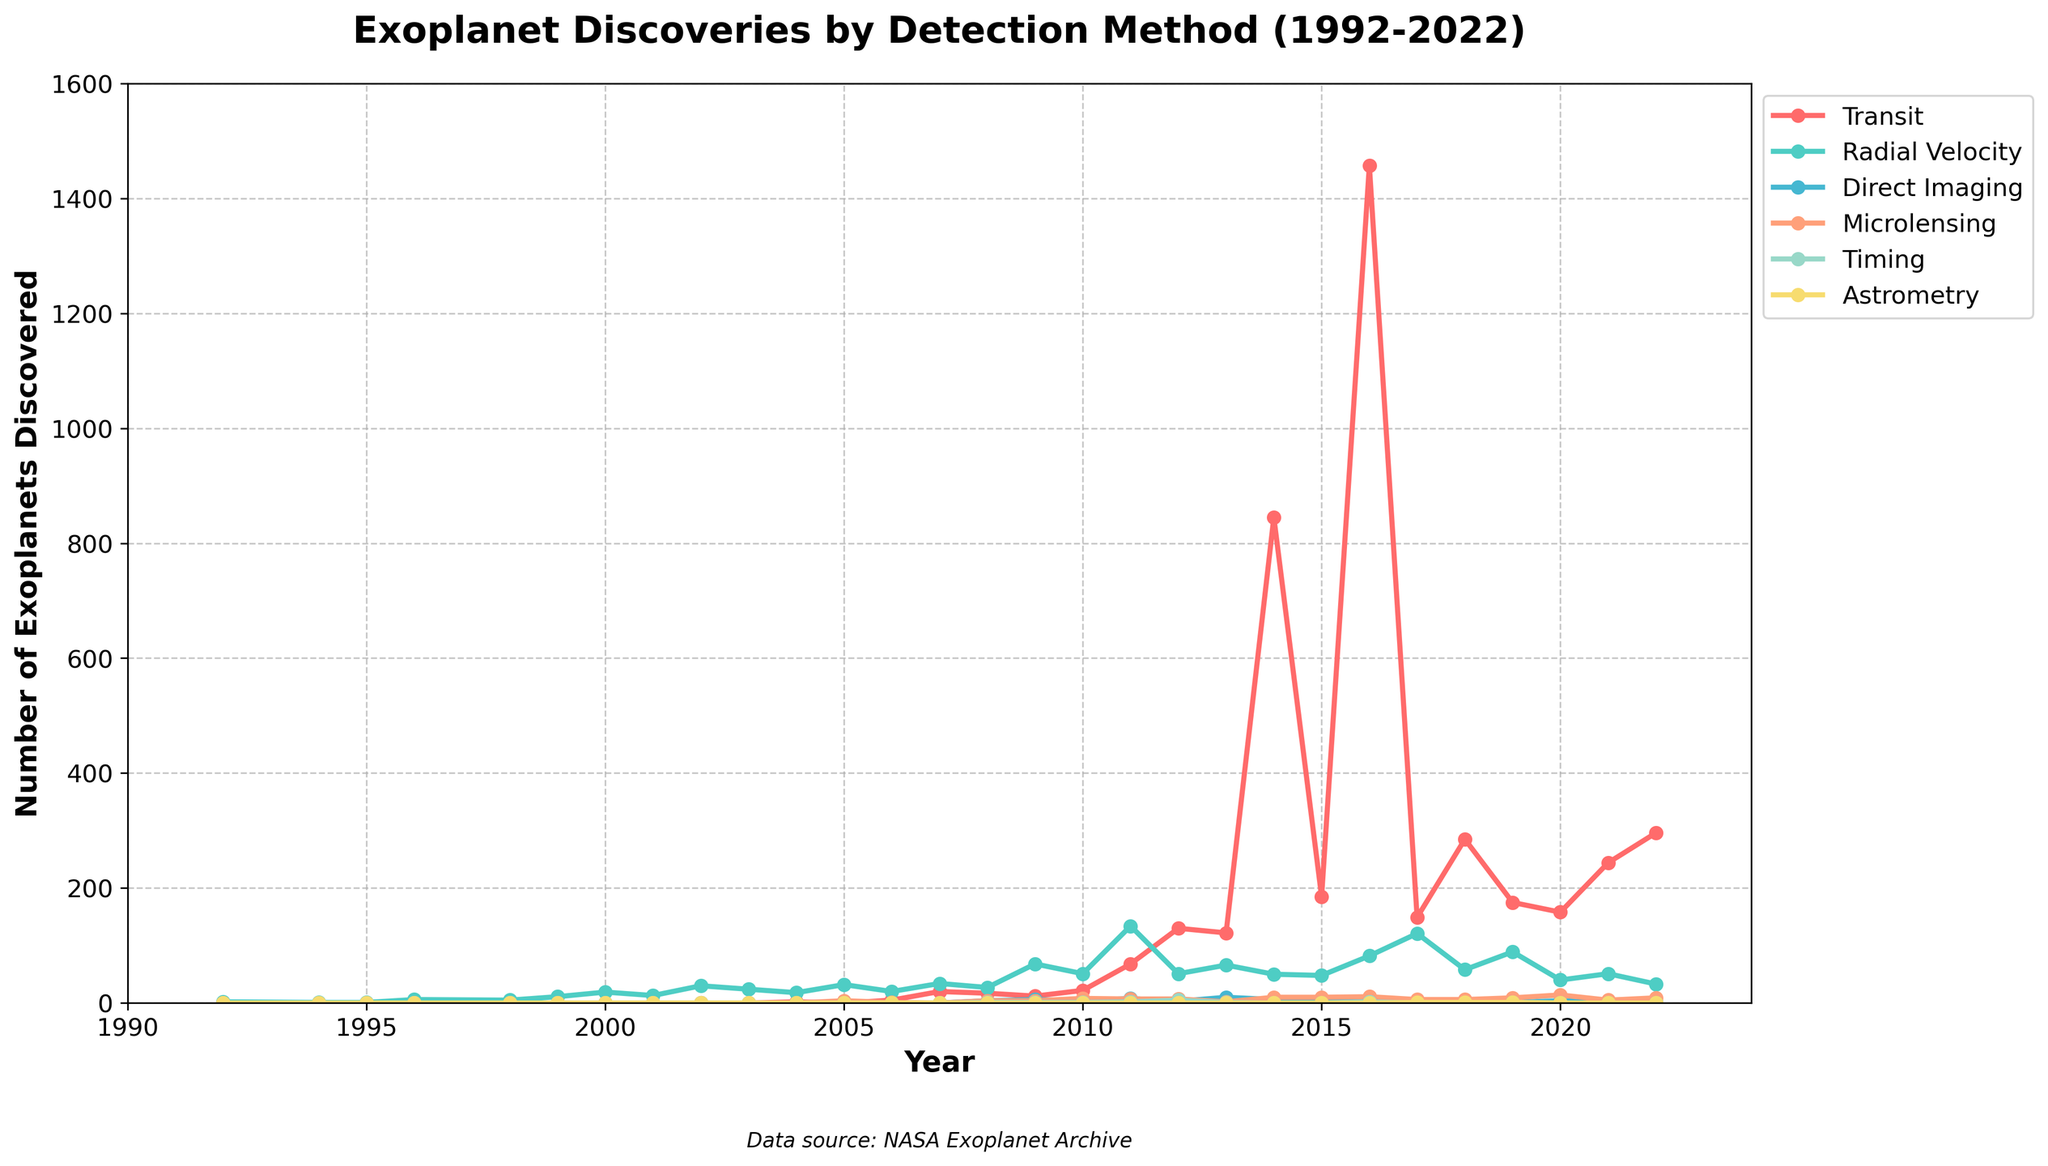Which year had the highest number of exoplanet discoveries using the direct imaging method? Find the curve corresponding to the direct imaging method. The highest point on this curve is in the year 2013 with 10 discoveries.
Answer: 2013 How many exoplanets were discovered in total using the radial velocity method in the year 2011? Look at the radial velocity curve for the year 2011. The data point shows 134 exoplanets.
Answer: 134 Which method saw a significant increase in discoveries between 2015 and 2016? Compare the heights of the curves for all methods between 2015 and 2016. The method with the most significant increase is the transit method, with the number of discoveries going from 185 in 2015 to 1457 in 2016.
Answer: Transit Compare the number of exoplanets discovered using the transit and microlensing methods in 2020. Which method had more discoveries and by how much? Look at the values for both methods in the year 2020. Transit had 158 discoveries, and microlensing had 14 discoveries. The difference is 158 - 14 = 144.
Answer: Transit by 144 What was the total number of exoplanets discovered across all methods in 2017? Add the values from all methods for the year 2017: 149 (Transit) + 121 (Radial Velocity) + 4 (Direct Imaging) + 6 (Microlensing) + 0 (Timing) + 1 (Astrometry) = 281.
Answer: 281 